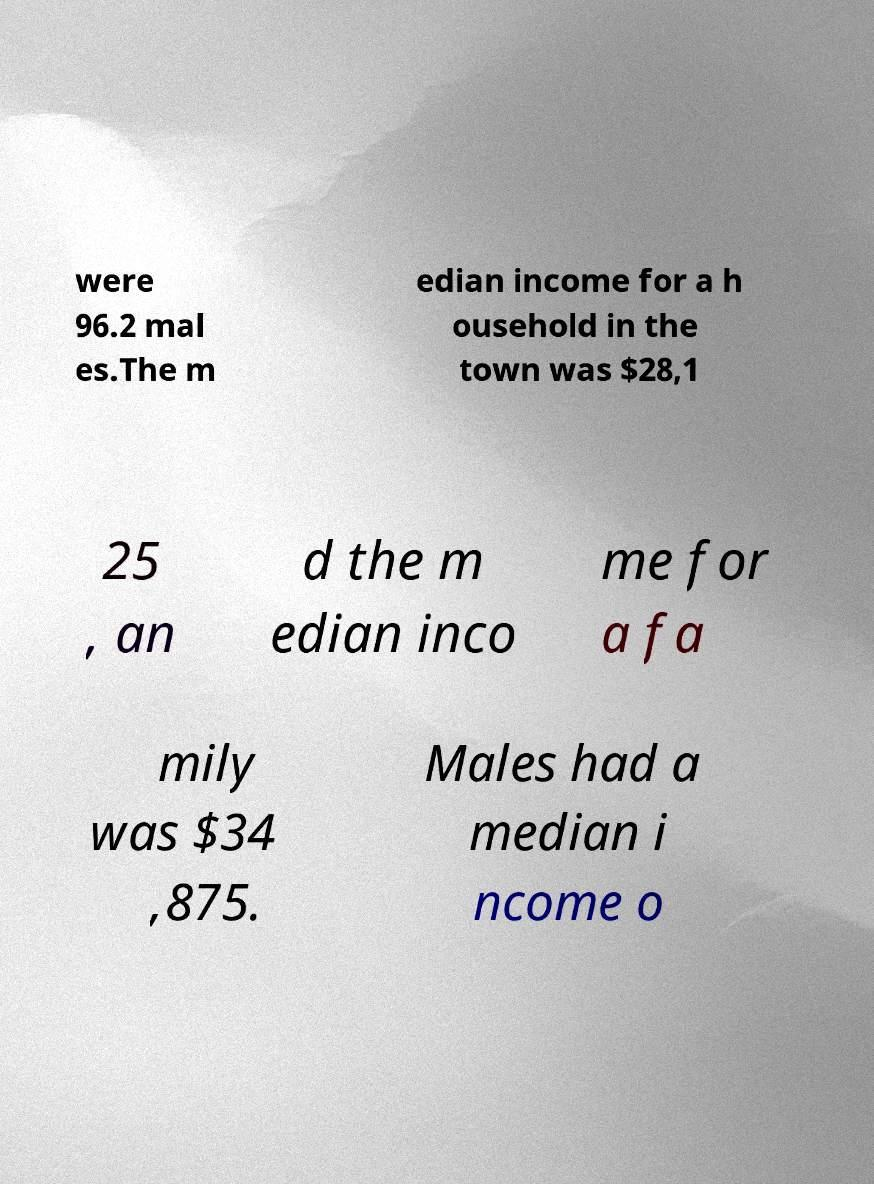Please identify and transcribe the text found in this image. were 96.2 mal es.The m edian income for a h ousehold in the town was $28,1 25 , an d the m edian inco me for a fa mily was $34 ,875. Males had a median i ncome o 